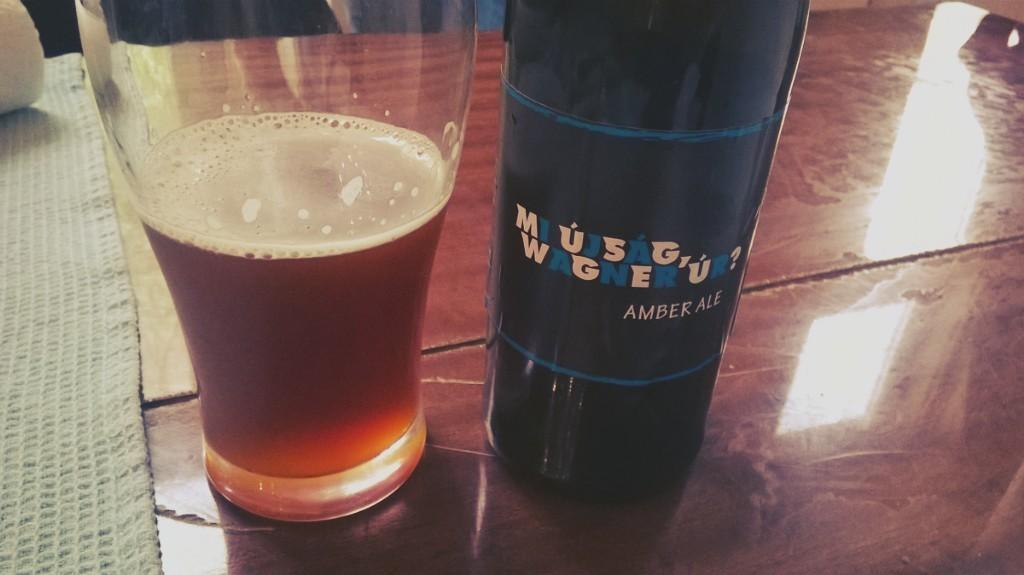<image>
Offer a succinct explanation of the picture presented. A bottle of Mi ujsag, Wagner ur? amber ale next to a glass that is half full of beer 